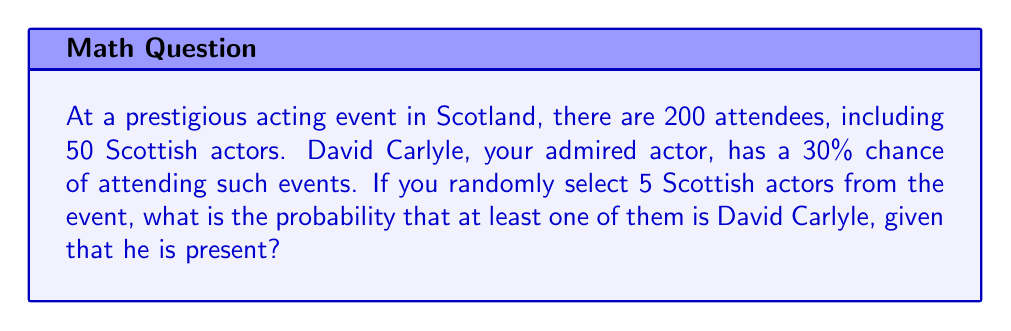Can you solve this math problem? Let's approach this step-by-step:

1) First, we need to calculate the probability that David Carlyle is present at the event:
   $P(\text{David present}) = 0.30$ (given in the question)

2) Now, given that David is present, we need to calculate the probability of selecting him when we choose 5 Scottish actors out of the 50 present.

3) The probability of not selecting David in one draw, given he's present, is:
   $P(\text{not David in one draw}) = \frac{49}{50}$

4) The probability of not selecting David in all 5 draws is:
   $P(\text{not David in 5 draws}) = (\frac{49}{50})^5$

5) Therefore, the probability of selecting David at least once in 5 draws is:
   $P(\text{at least one David}) = 1 - (\frac{49}{50})^5$

6) Let's calculate this:
   $$1 - (\frac{49}{50})^5 = 1 - 0.9039 = 0.0961$$

7) This probability is conditional on David being present. To get the final probability, we need to multiply by the probability of David being present:

   $$P(\text{at least one David and David present}) = 0.0961 \times 0.30 = 0.02883$$
Answer: $0.02883$ or approximately $2.88\%$ 